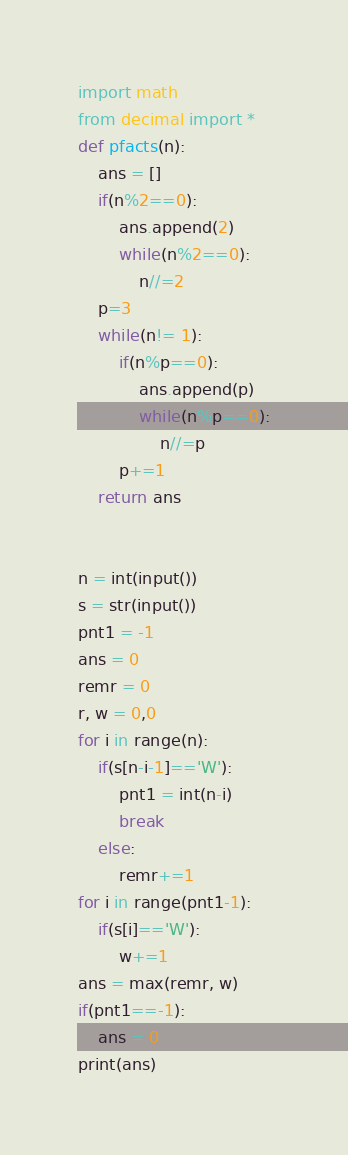<code> <loc_0><loc_0><loc_500><loc_500><_Python_>import math
from decimal import *
def pfacts(n):
    ans = []
    if(n%2==0):
        ans.append(2)
        while(n%2==0):
            n//=2
    p=3
    while(n!= 1):
        if(n%p==0):
            ans.append(p)
            while(n%p==0):
                n//=p
        p+=1
    return ans


n = int(input())
s = str(input())
pnt1 = -1
ans = 0
remr = 0
r, w = 0,0
for i in range(n):
    if(s[n-i-1]=='W'):
        pnt1 = int(n-i)
        break
    else:
        remr+=1
for i in range(pnt1-1):
    if(s[i]=='W'):
        w+=1
ans = max(remr, w)
if(pnt1==-1):
    ans = 0
print(ans)</code> 